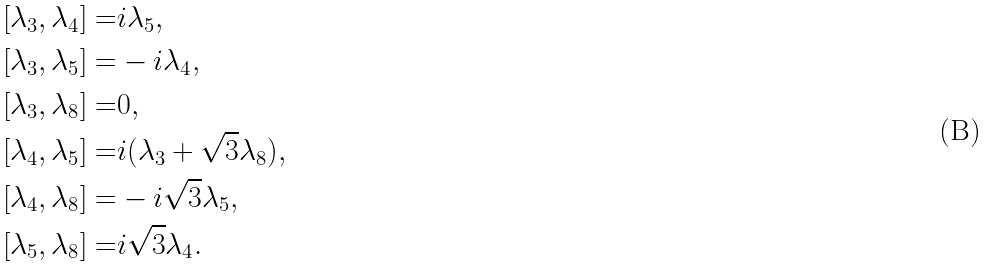Convert formula to latex. <formula><loc_0><loc_0><loc_500><loc_500>[ \lambda _ { 3 } , \lambda _ { 4 } ] = & i \lambda _ { 5 } , \\ [ \lambda _ { 3 } , \lambda _ { 5 } ] = & - i \lambda _ { 4 } , \\ [ \lambda _ { 3 } , \lambda _ { 8 } ] = & 0 , \\ [ \lambda _ { 4 } , \lambda _ { 5 } ] = & i ( \lambda _ { 3 } + \sqrt { 3 } \lambda _ { 8 } ) , \\ [ \lambda _ { 4 } , \lambda _ { 8 } ] = & - i \sqrt { 3 } \lambda _ { 5 } , \\ [ \lambda _ { 5 } , \lambda _ { 8 } ] = & i \sqrt { 3 } \lambda _ { 4 } .</formula> 